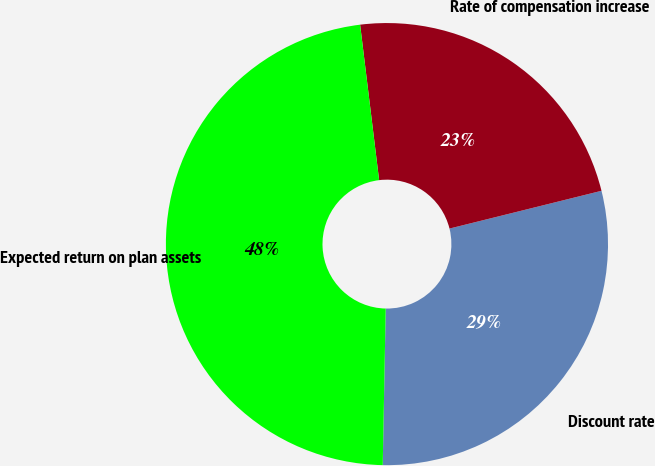Convert chart. <chart><loc_0><loc_0><loc_500><loc_500><pie_chart><fcel>Discount rate<fcel>Rate of compensation increase<fcel>Expected return on plan assets<nl><fcel>29.18%<fcel>23.06%<fcel>47.76%<nl></chart> 